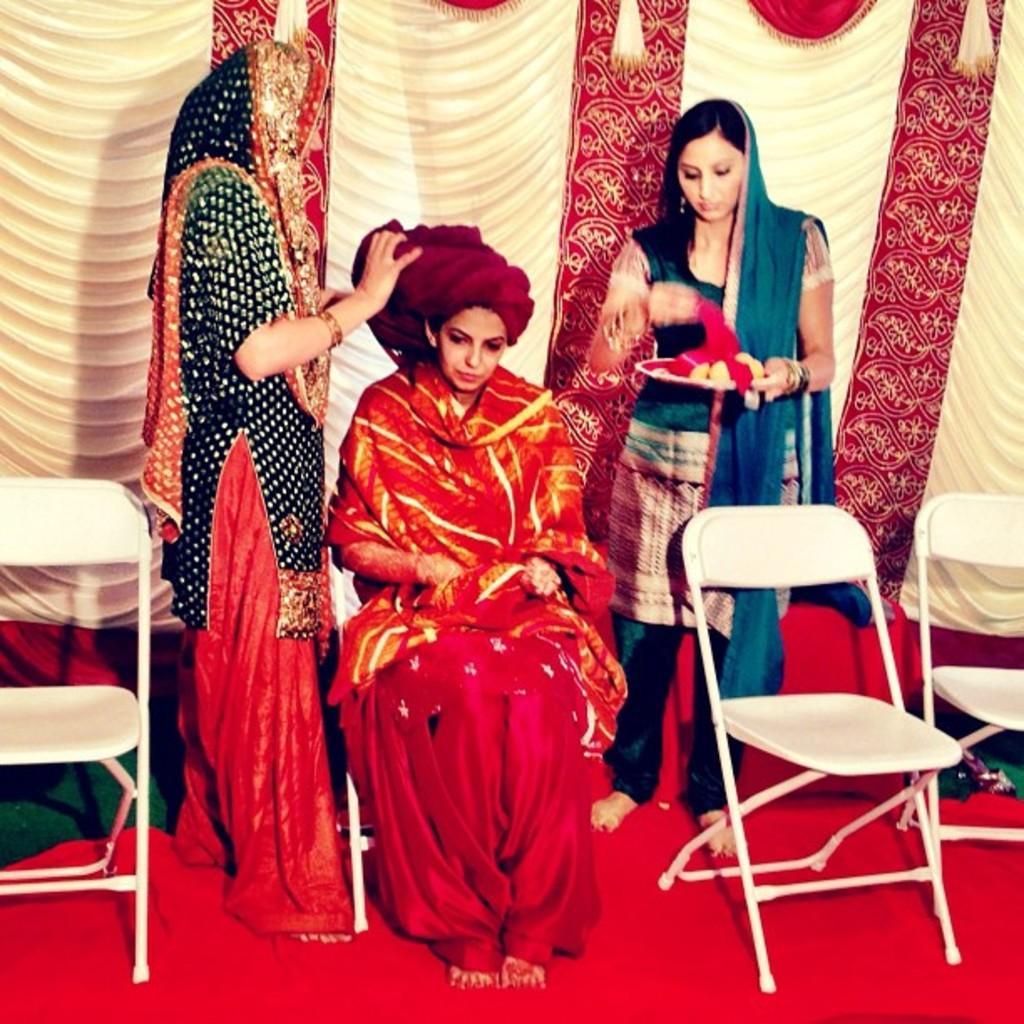Could you give a brief overview of what you see in this image? In this image I can see one woman sitting on the chair with red cloth on her head and two woman standing. This women is holding a tray with a red color cloth on her hand. These are the three empty chairs. This is the red carpet on the floor. At background I can see cloth hanging which is cream and maroon in color. 